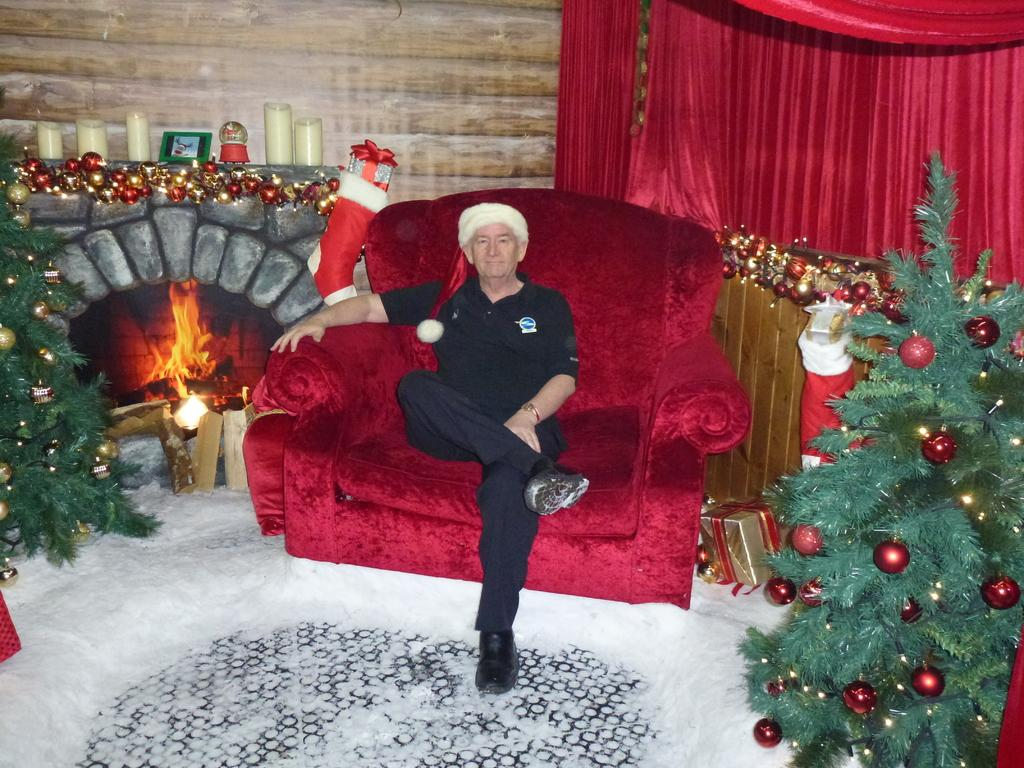What is the condition of the ground in the image? There is snow on the ground in the image. What is hanging on the trees in the image? The trees have balls hanging from them. What type of furniture is present in the image? There is a sofa in the image. Who is sitting on the sofa in the image? There is a man sitting on the sofa in the image. What can be seen on the left side of the image? There is a flame on the left side of the image. What type of window treatment is present in the image? There is a red color curtain in the image. What is the man's mom doing in the image? There is no mention of the man's mom in the image, so we cannot answer that question. How many arms does the sofa have in the image? The sofa is a piece of furniture and does not have arms like a person or animal would. 